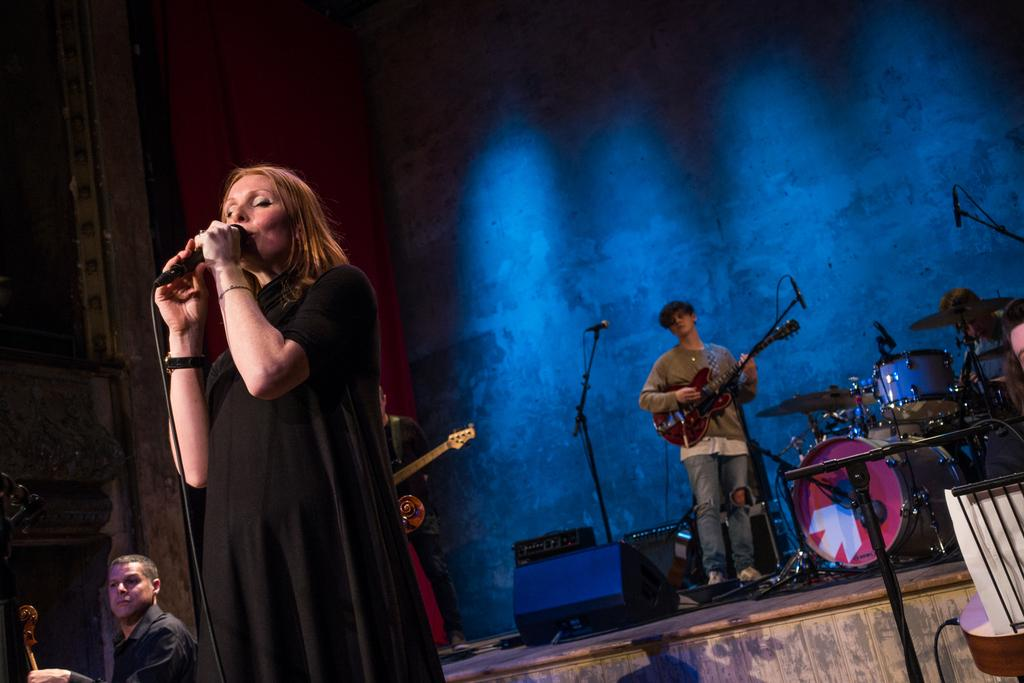What is happening in the image? There are people in the image, and some of them are holding musical instruments. Can you describe the woman in the image? The woman is holding a microphone. What is the person sitting next to doing? The person sitting next to a drum set is likely preparing to play the drums. How many kittens are running around in the image? There are no kittens present in the image. Can you describe the jump performed by the person holding the guitar? There is no person jumping in the image, and no one is holding a guitar. 